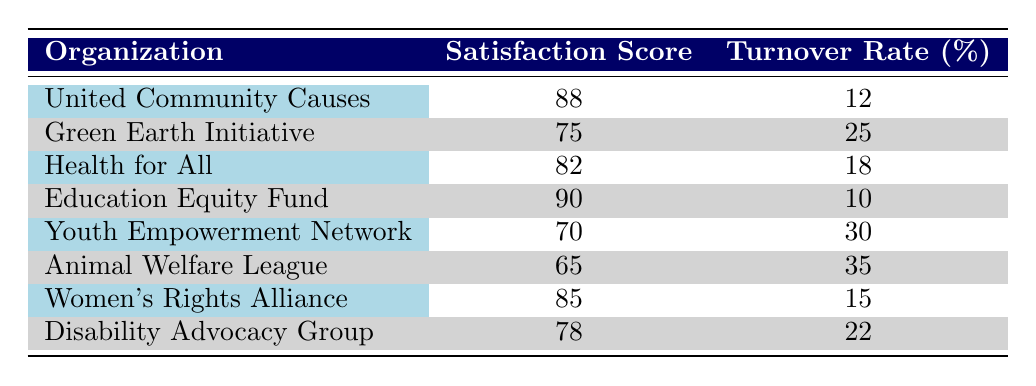What is the satisfaction score for the Education Equity Fund? The table lists the satisfaction score for each organization, and the Education Equity Fund's score is provided directly under that organization's name. By looking at the table, the score for the Education Equity Fund is 90.
Answer: 90 Which organization has the highest turnover rate? The turnover rate for each organization is shown in the table. By comparing the turnover rates, the organization with the highest turnover rate is the Animal Welfare League, which has a turnover rate of 35%.
Answer: Animal Welfare League What is the average satisfaction score of all organizations listed? To find the average satisfaction score, sum the satisfaction scores of all organizations: 88 + 75 + 82 + 90 + 70 + 65 + 85 + 78 =  633. There are 8 organizations, so dividing the total by 8 gives an average of 633 / 8 = 79.125.
Answer: 79.125 Does the Women's Rights Alliance have a turnover rate lower than 20%? The turnover rate for the Women's Rights Alliance is listed in the table as 15%. Since 15% is lower than 20%, this statement is true.
Answer: Yes Can you identify an organization that has both a high satisfaction score and a low turnover rate? Evaluating the table, the Education Equity Fund has a satisfaction score of 90 and a turnover rate of 10%. Both values indicate high satisfaction and low turnover, meeting the criteria of the question.
Answer: Education Equity Fund What is the difference in turnover rates between the highest and lowest turnover rate organizations? The highest turnover rate, as identified earlier, is from the Animal Welfare League at 35%. The lowest turnover rate from the Education Equity Fund is 10%. The difference between these two rates is 35 - 10 = 25%.
Answer: 25% Is there any organization with a satisfaction score above 80% and a turnover rate below 15%? Checking the table, the organizations that meet the conditions of a satisfaction score above 80% and a turnover rate below 15% are the United Community Causes (satisfaction score 88, turnover rate 12%) and the Education Equity Fund (satisfaction score 90, turnover rate 10%). Thus, there are indeed organizations that meet these criteria.
Answer: Yes How many organizations have a satisfaction score below 80? By reviewing the table, the organizations with a satisfaction score below 80% are the Green Earth Initiative (75), Youth Empowerment Network (70), and Animal Welfare League (65). There are a total of 3 organizations with satisfaction scores below 80%.
Answer: 3 